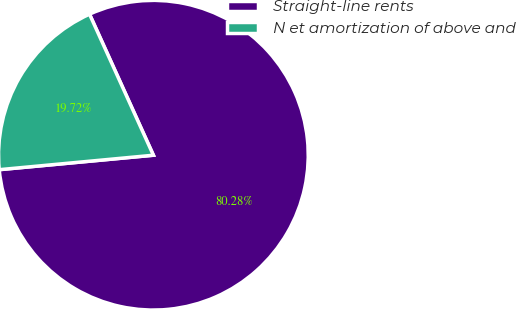Convert chart to OTSL. <chart><loc_0><loc_0><loc_500><loc_500><pie_chart><fcel>Straight-line rents<fcel>N et amortization of above and<nl><fcel>80.28%<fcel>19.72%<nl></chart> 